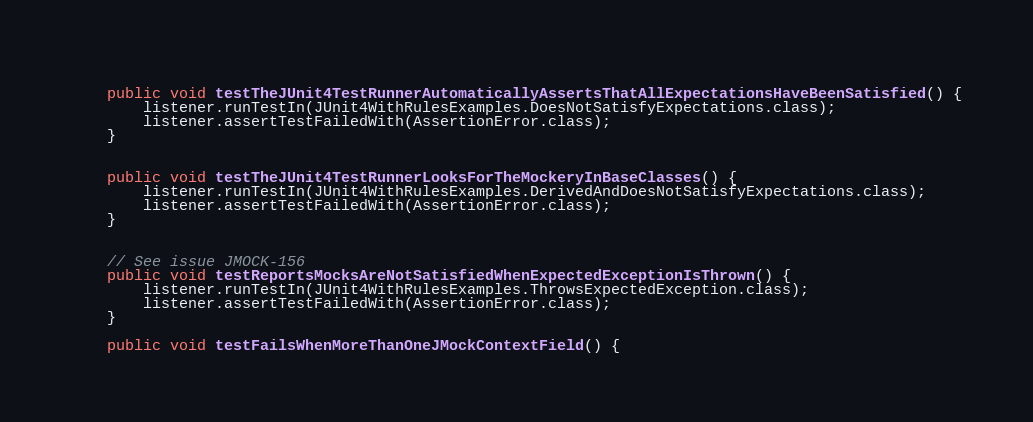Convert code to text. <code><loc_0><loc_0><loc_500><loc_500><_Java_>    
    public void testTheJUnit4TestRunnerAutomaticallyAssertsThatAllExpectationsHaveBeenSatisfied() {
        listener.runTestIn(JUnit4WithRulesExamples.DoesNotSatisfyExpectations.class);
        listener.assertTestFailedWith(AssertionError.class);
    }
    
    
    public void testTheJUnit4TestRunnerLooksForTheMockeryInBaseClasses() {
        listener.runTestIn(JUnit4WithRulesExamples.DerivedAndDoesNotSatisfyExpectations.class);
        listener.assertTestFailedWith(AssertionError.class);
    }

    
    // See issue JMOCK-156
    public void testReportsMocksAreNotSatisfiedWhenExpectedExceptionIsThrown() {
        listener.runTestIn(JUnit4WithRulesExamples.ThrowsExpectedException.class);
        listener.assertTestFailedWith(AssertionError.class);
    }
    
    public void testFailsWhenMoreThanOneJMockContextField() {</code> 